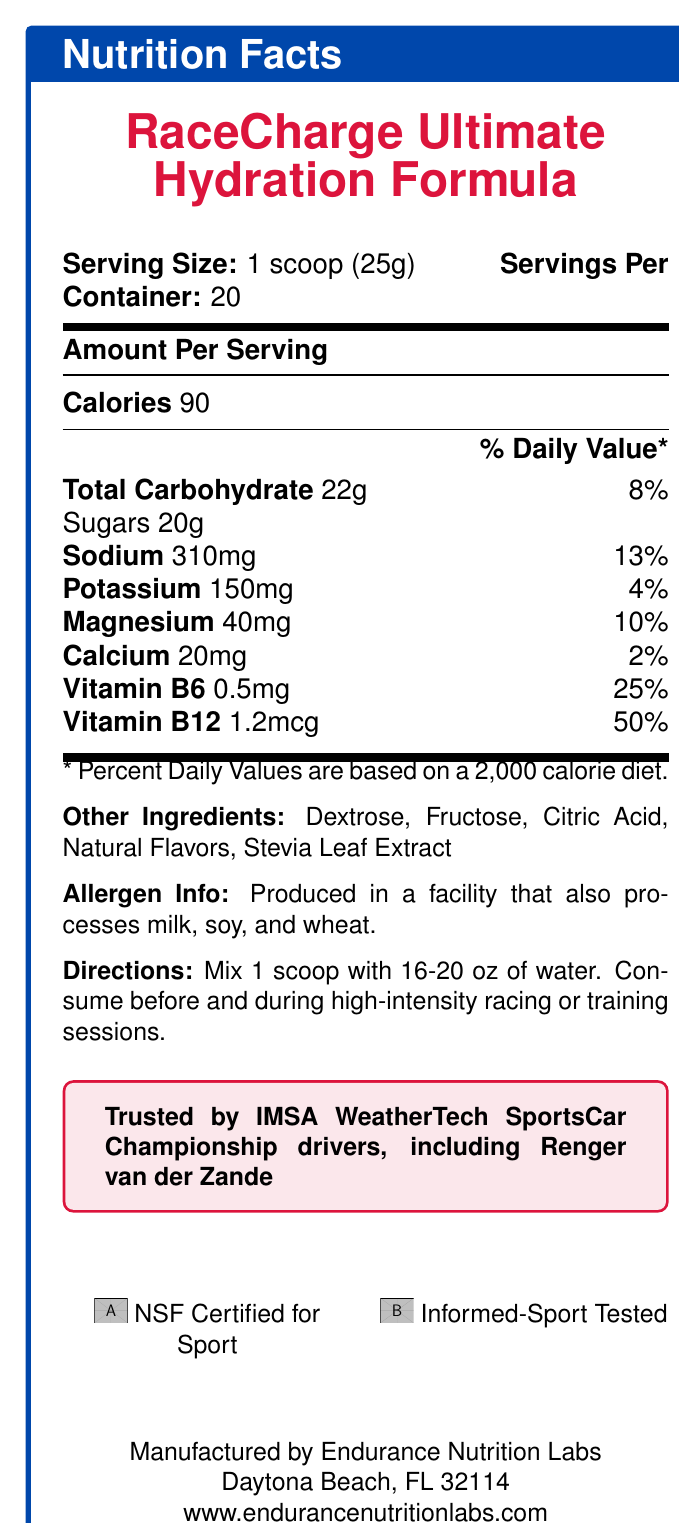What is the serving size for RaceCharge Ultimate Hydration Formula? The serving size is mentioned at the beginning of the document under the title "Serving Size".
Answer: 1 scoop (25g) How many servings are there per container of RaceCharge Ultimate Hydration Formula? The document states "Servings Per Container: 20" right after mentioning the serving size.
Answer: 20 How many calories does one serving of RaceCharge Ultimate Hydration Formula contain? Under the "Amount Per Serving" section, it mentions that there are 90 calories per serving.
Answer: 90 What percentage of the daily value for sodium does one scoop provide? In the nutrients section, it is mentioned that one scoop provides 310mg of sodium, which is 13% of the daily value.
Answer: 13% What is the main carbohydrate source in RaceCharge Ultimate Hydration Formula? The "Total Carbohydrate" section states 22g, with sugars making up 20g of this total.
Answer: Sugars (20g) Which vitamins are included in RaceCharge Ultimate Hydration Formula? The document lists Vitamin B6 (0.5mg, 25% daily value) and Vitamin B12 (1.2mcg, 50% daily value).
Answer: Vitamin B6 and Vitamin B12 What should you mix the RaceCharge Ultimate Hydration Formula with, and how much? The directions specify that you should mix 1 scoop with 16-20 oz of water.
Answer: 16-20 oz of water Who is one of the IMSA WeatherTech SportsCar Championship drivers endorsing this product? The document states that the product is trusted by drivers, including Renger van der Zande.
Answer: Renger van der Zande Which ingredient acts as a natural sweetener in RaceCharge Ultimate Hydration Formula? In the "Other Ingredients" list, Stevia Leaf Extract is mentioned as a natural sweetener.
Answer: Stevia Leaf Extract What certifications does RaceCharge Ultimate Hydration Formula have? At the bottom of the document, the certifications "NSF Certified for Sport" and "Informed-Sport Tested" are mentioned.
Answer: NSF Certified for Sport, Informed-Sport Tested Is the RaceCharge Ultimate Hydration Formula suitable for individuals with milk allergies? The allergen info states that it is produced in a facility that processes milk, soy, and wheat, which may pose a risk for individuals with these allergies.
Answer: No How much potassium is in one serving of RaceCharge Ultimate Hydration Formula? The document specifies that one serving contains 150mg of potassium.
Answer: 150mg What company manufactures the RaceCharge Ultimate Hydration Formula? At the bottom of the document, it states that the product is manufactured by Endurance Nutrition Labs, located in Daytona Beach, FL.
Answer: Endurance Nutrition Labs What is the daily value percentage of Vitamin B12 provided by one scoop? In the nutrients section, it is indicated that one serving provides 1.2mcg of Vitamin B12, which is 50% of the daily value.
Answer: 50% How many grams of total carbohydrate does one serving of RaceCharge Ultimate Hydration Formula have? The "Total Carbohydrate" section states that there are 22g total carbohydrates per serving.
Answer: 22g Which of the following ingredients is not listed in the RaceCharge Ultimate Hydration Formula?
A. Dextrose
B. Fructose
C. Aspartame
D. Stevia Leaf Extract Aspartame is not listed in the "Other Ingredients" section. The other options are among the ingredients.
Answer: C What is the name of the product described in the document?
A. SpeedFuel
B. RaceCharge Ultimate Hydration Formula
C. EndurancePro
D. HydrateMax The document indicates the product name is "RaceCharge Ultimate Hydration Formula".
Answer: B Can the document explain how often you should consume the product? The document explains how to prepare and when to consume the product but does not specify the frequency of consumption.
Answer: No Summarize the main details of the RaceCharge Ultimate Hydration Formula Nutrition Facts Label. The document serves to inform the consumer about the nutritional content, ingredients, and proper use of the hydration formula, as well as endorse the product with certifications and athlete endorsements.
Answer: The document provides detailed nutritional information for RaceCharge Ultimate Hydration Formula, including serving size, servings per container, caloric content, and nutrient amounts and percentages of daily values. It lists ingredients, allergen information, usage directions, and endorsements, and mentions certifications and manufacturer details. What is the contact email or phone number for Endurance Nutrition Labs? The document only provides the website and location for Endurance Nutrition Labs, but no email or phone number is provided.
Answer: Cannot be determined 